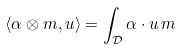<formula> <loc_0><loc_0><loc_500><loc_500>\langle \alpha \otimes m , u \rangle = \int _ { \mathcal { D } } \alpha \cdot u \, m</formula> 